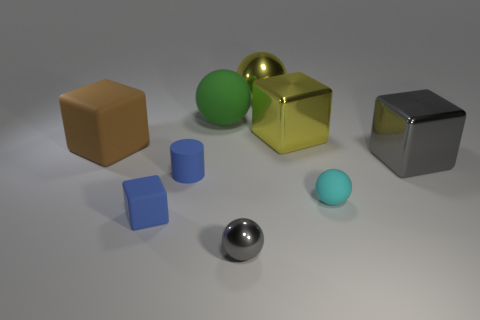Add 1 large brown metal objects. How many objects exist? 10 Subtract all spheres. How many objects are left? 5 Subtract 1 gray spheres. How many objects are left? 8 Subtract all tiny gray objects. Subtract all small green cylinders. How many objects are left? 8 Add 6 big metal things. How many big metal things are left? 9 Add 1 small balls. How many small balls exist? 3 